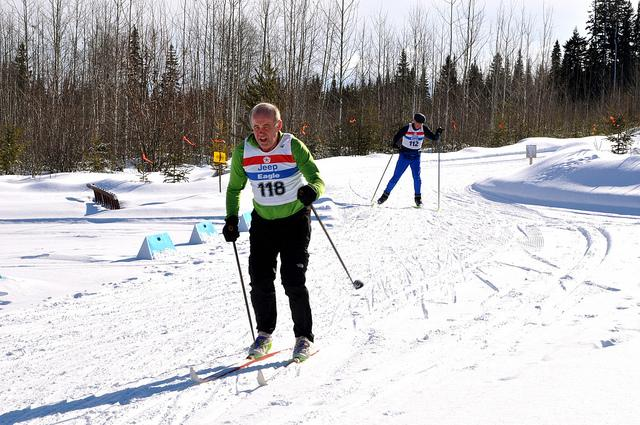What number is on the man in the green shirt's jersey?

Choices:
A) 118
B) 415
C) 223
D) 956 118 